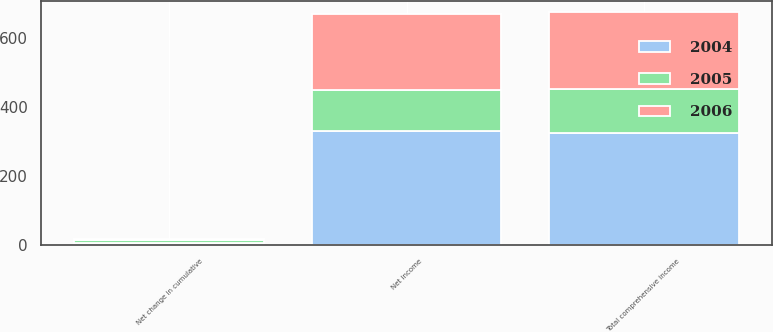<chart> <loc_0><loc_0><loc_500><loc_500><stacked_bar_chart><ecel><fcel>Net income<fcel>Net change in cumulative<fcel>Total comprehensive income<nl><fcel>2004<fcel>328.9<fcel>4.6<fcel>324.3<nl><fcel>2006<fcel>221.5<fcel>3.4<fcel>223.4<nl><fcel>2005<fcel>120.3<fcel>8.3<fcel>127.1<nl></chart> 